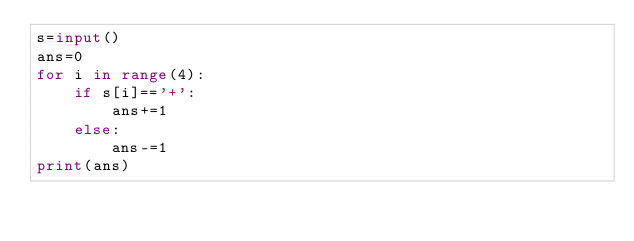<code> <loc_0><loc_0><loc_500><loc_500><_Python_>s=input()
ans=0
for i in range(4):
    if s[i]=='+':
        ans+=1
    else:
        ans-=1
print(ans)</code> 